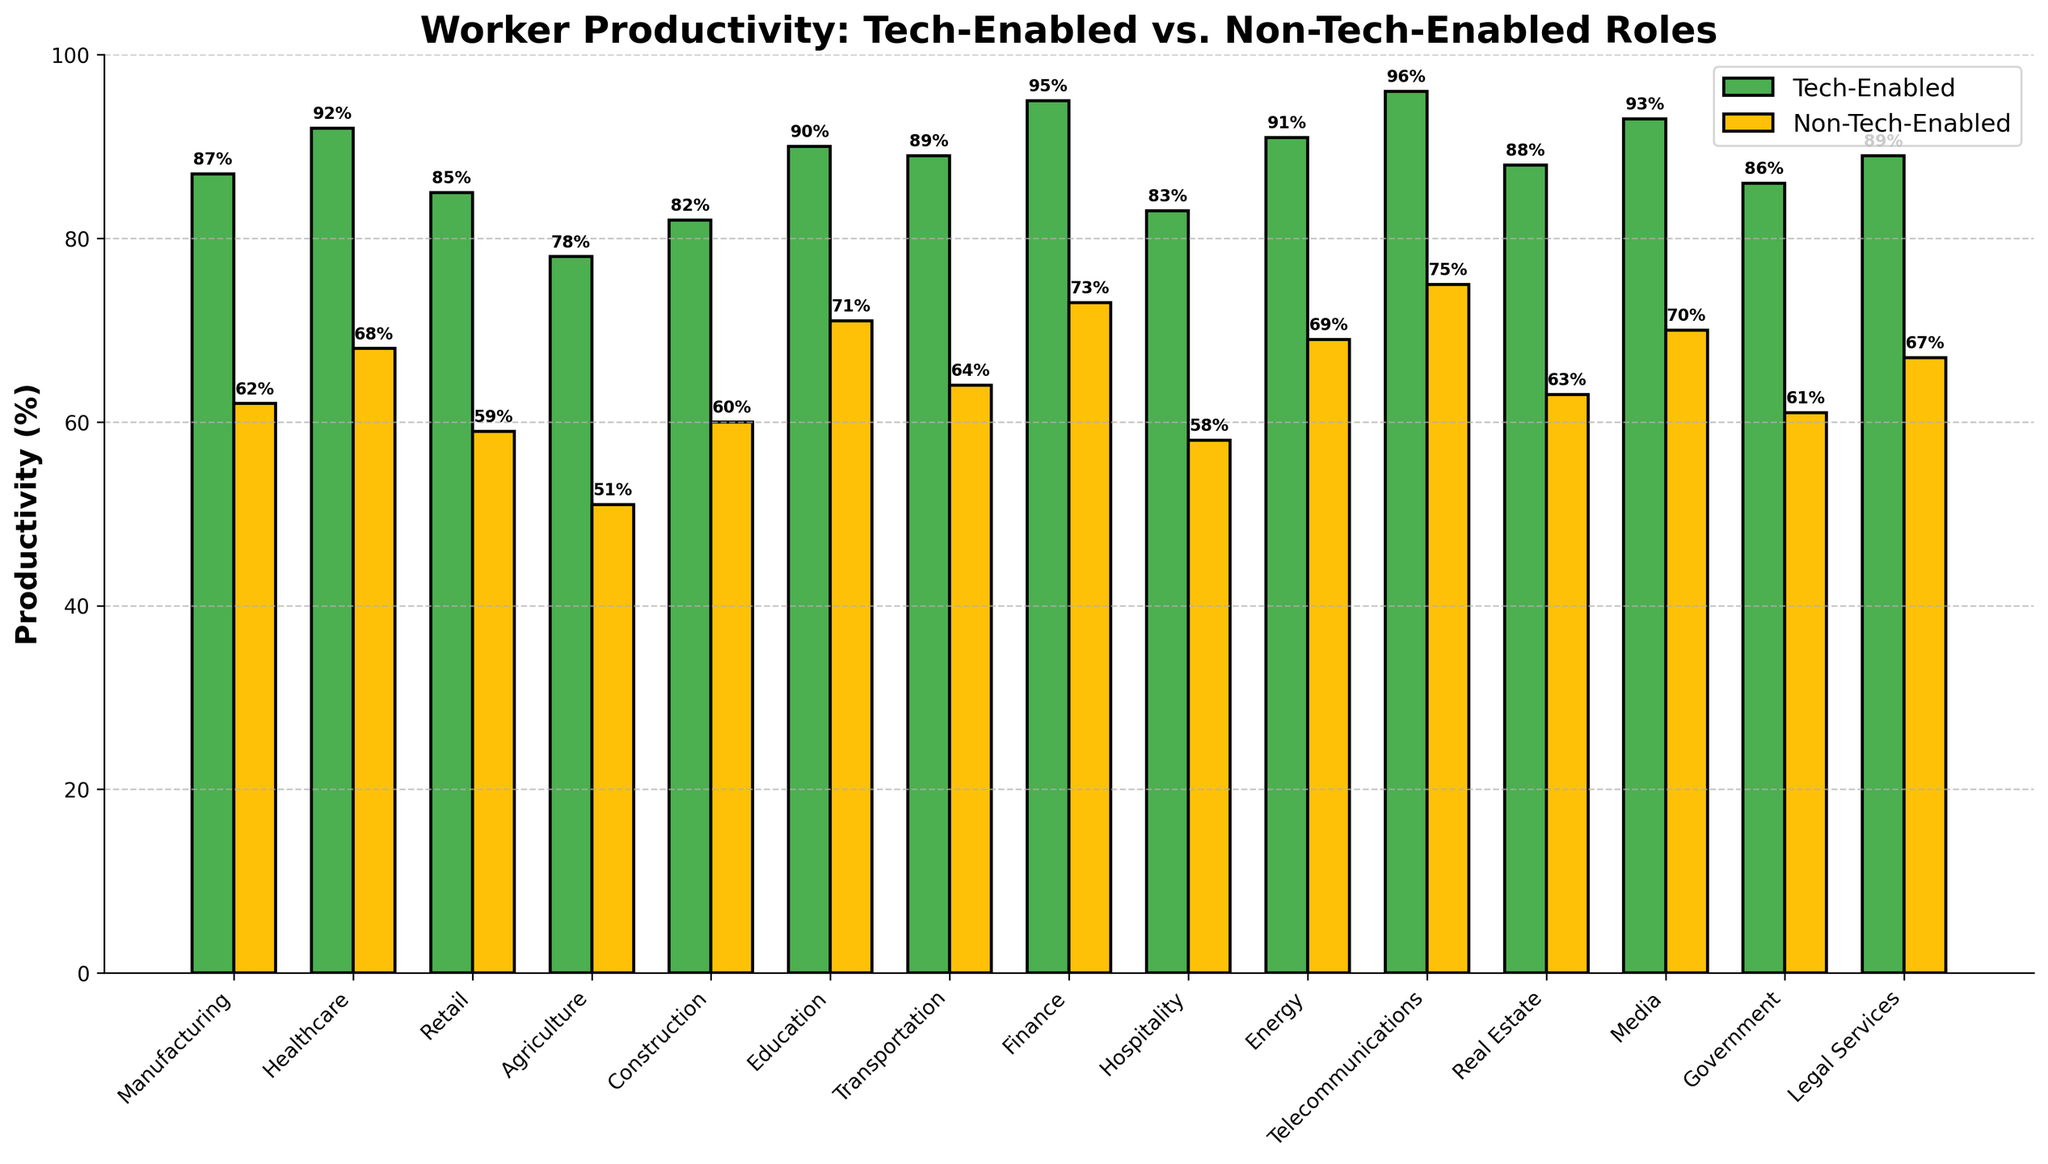What's the difference in productivity between tech-enabled and non-tech-enabled roles in manufacturing? The productivity for tech-enabled roles in manufacturing is 87%, while for non-tech-enabled roles it is 62%. The difference is calculated as 87 - 62 = 25.
Answer: 25% Which sector shows the highest productivity in tech-enabled roles? By comparing the tech-enabled productivity values across all sectors, telecommunications has the highest productivity at 96%.
Answer: Telecommunications What is the average productivity of non-tech-enabled roles across all sectors? To calculate the average, sum up all the productivity percentages for non-tech-enabled roles and divide by the number of sectors. The sum is 62+68+59+51+60+71+64+73+58+69+75+63+70+61+67 = 901. There are 15 sectors, so the average is 901/15 = 60.07.
Answer: 60.07% Compare the productivity in healthcare between tech-enabled and non-tech-enabled roles. What do you observe? In healthcare, tech-enabled productivity is 92% and non-tech-enabled productivity is 68%. Tech-enabled roles result in 24% higher productivity.
Answer: 24% higher for tech-enabled Which sector has the smallest difference in productivity between tech-enabled and non-tech-enabled roles, and what is the difference? Calculate the differences for each sector:  
Manufacturing: 25  
Healthcare: 24  
Retail: 26  
Agriculture: 27  
Construction: 22  
Education: 19  
Transportation: 25  
Finance: 22  
Hospitality: 25  
Energy: 22  
Telecommunications: 21  
Real Estate: 25  
Media: 23  
Government: 25  
Legal Services: 22  
The smallest difference is in Education with a 19% difference.
Answer: Education, 19% What is the combined productivity of tech-enabled and non-tech-enabled roles in the Construction sector? Sum the productivity percentages for both roles in the Construction sector: 82 (tech-enabled) + 60 (non-tech-enabled) = 142.
Answer: 142% Among Education, Media, and Legal Services, which sector has the highest tech-enabled productivity? Compare the tech-enabled productivity percentages:  
Education: 90%  
Media: 93%  
Legal Services: 89%  
Media has the highest tech-enabled productivity at 93%.
Answer: Media What is the median productivity for non-tech-enabled roles? Arrange the non-tech-enabled productivity percentages in ascending order: 51, 58, 59, 60, 61, 62, 63, 64, 67, 68, 69, 70, 71, 73, 75. The middle value is the 8th value since there are 15 values, which is 64.
Answer: 64% Which sectors exhibit a tech-enabled productivity greater than 90%? Check tech-enabled productivity percentages: Healthcare (92%), Finance (95%), Energy (91%), Telecommunications (96%), Media (93%). These sectors have tech-enabled productivity greater than 90%.
Answer: Healthcare, Finance, Energy, Telecommunications, Media Compare the productivity in government between tech-enabled and non-tech-enabled roles. What do you observe? In government, tech-enabled productivity is 86%, and non-tech-enabled productivity is 61%. Tech-enabled roles result in 25% higher productivity.
Answer: 25% higher for tech-enabled 